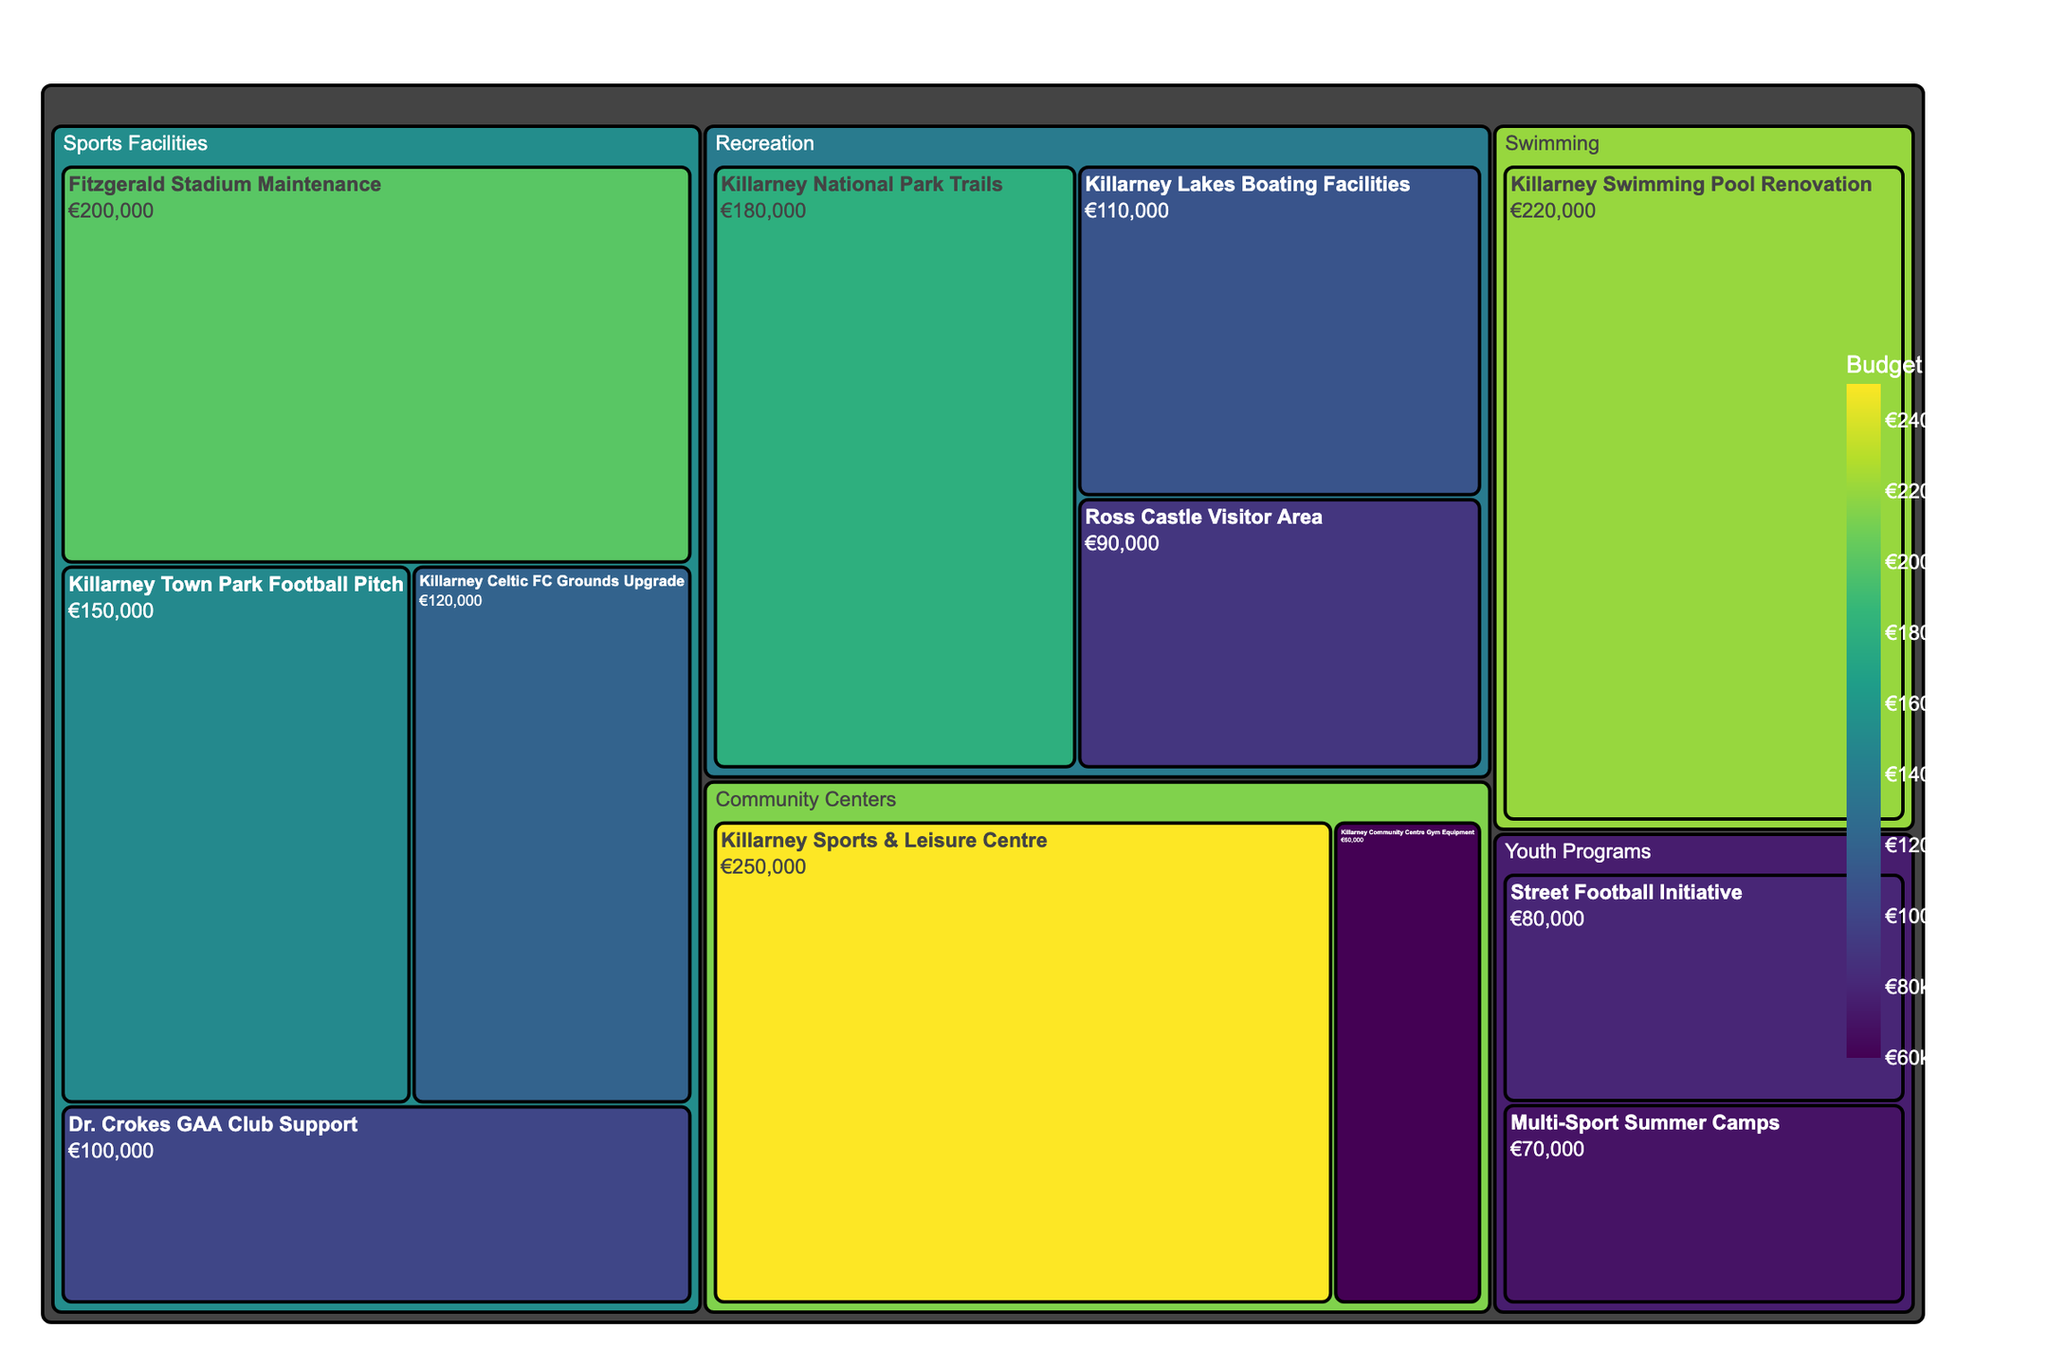What's the title of the figure? The title is usually at the top of the figure and describes what it represents. In this case, it tells us it's a budget allocation for sports and recreation.
Answer: Killarney Municipal Budget Allocation for Sports and Recreation How much budget is allocated to the 'Killarney Sports & Leisure Centre'? The budget allocations are indicated in the treemap for each subcategory. Look for 'Killarney Sports & Leisure Centre' in the 'Community Centers' category.
Answer: €250,000 Which subcategory within 'Sports Facilities' has the highest budget allocation? Within the 'Sports Facilities' category, compare the budgets of all subcategories and identify the one with the highest amount.
Answer: Fitzgerald Stadium Maintenance What is the total budget allocation for the 'Recreation' category? Add the amounts for all subcategories under 'Recreation': Killarney National Park Trails (€180,000), Ross Castle Visitor Area (€90,000), and Killarney Lakes Boating Facilities (€110,000).
Answer: €380,000 Is the budget allocation for 'Killarney Swimming Pool Renovation' greater than the 'Killarney National Park Trails'? Compare the budget amounts of both subcategories. Killarney Swimming Pool Renovation has €220,000, while Killarney National Park Trails has €180,000.
Answer: Yes Which category received the highest total budget allocation? Sum the amounts for each category and compare the totals. Community Centers have €310,000, Sports Facilities have €570,000, Recreation has €380,000, and Youth Programs have €150,000. Sports Facilities have the highest total.
Answer: Sports Facilities Is the budget allocation for 'Dr. Crokes GAA Club Support' less than 'Street Football Initiative'? Compare the amounts: Dr. Crokes GAA Club Support has €100,000, and Street Football Initiative has €80,000.
Answer: No Which subcategory has the smallest budget allocation, and how much is it? Identify the subcategory with the smallest amount in the treemap. Multi-Sport Summer Camps has the smallest amount.
Answer: Multi-Sport Summer Camps, €70,000 